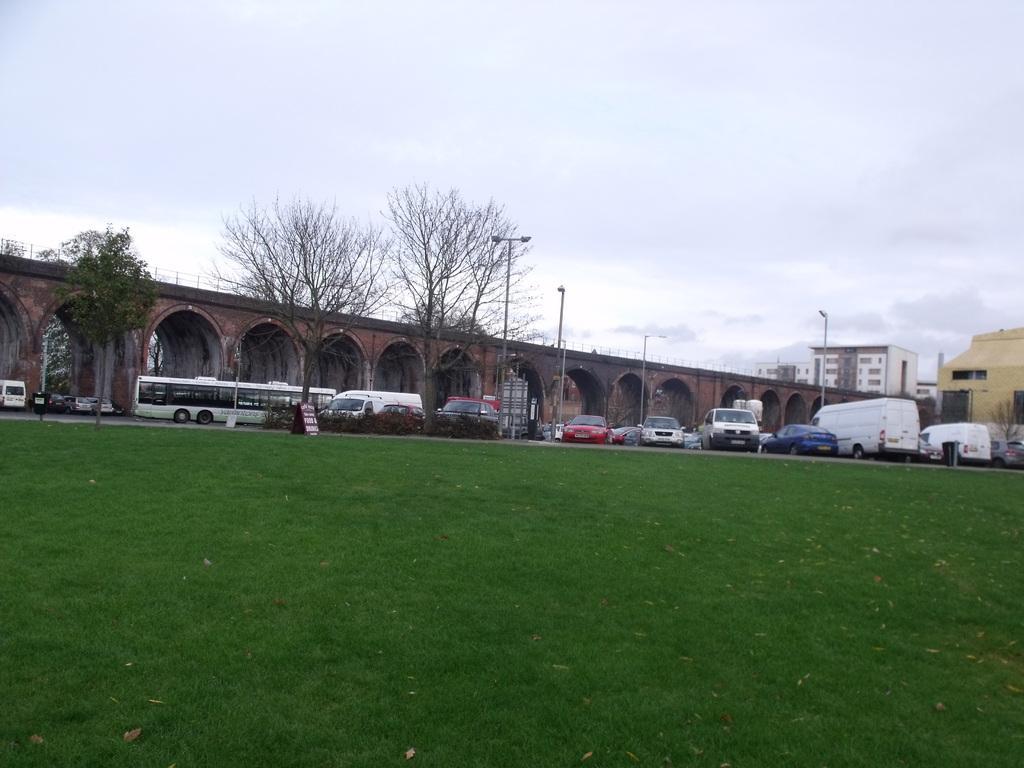Please provide a concise description of this image. In this picture I can see the grass in front and in the middle of this picture I can see number of vehicles, few trees, poles, a bridge and few buildings on the right. In the background I can see the sky which is a bit cloudy. 